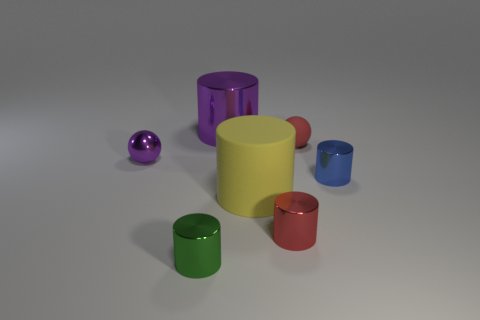What size is the metal cylinder that is the same color as the tiny rubber ball?
Provide a short and direct response. Small. The other metal thing that is the same color as the big metal thing is what shape?
Provide a short and direct response. Sphere. How many other objects are there of the same material as the red sphere?
Give a very brief answer. 1. How many big objects are brown cylinders or purple metal things?
Ensure brevity in your answer.  1. Is the small green object made of the same material as the blue cylinder?
Offer a terse response. Yes. There is a matte thing behind the small blue metallic cylinder; how many big things are in front of it?
Your answer should be very brief. 1. Is there a blue object of the same shape as the small purple object?
Your answer should be compact. No. Do the purple thing that is in front of the large purple cylinder and the purple shiny thing that is right of the green shiny thing have the same shape?
Make the answer very short. No. The tiny metal object that is on the left side of the red cylinder and behind the small green thing has what shape?
Keep it short and to the point. Sphere. Are there any blue cylinders that have the same size as the green object?
Provide a short and direct response. Yes. 